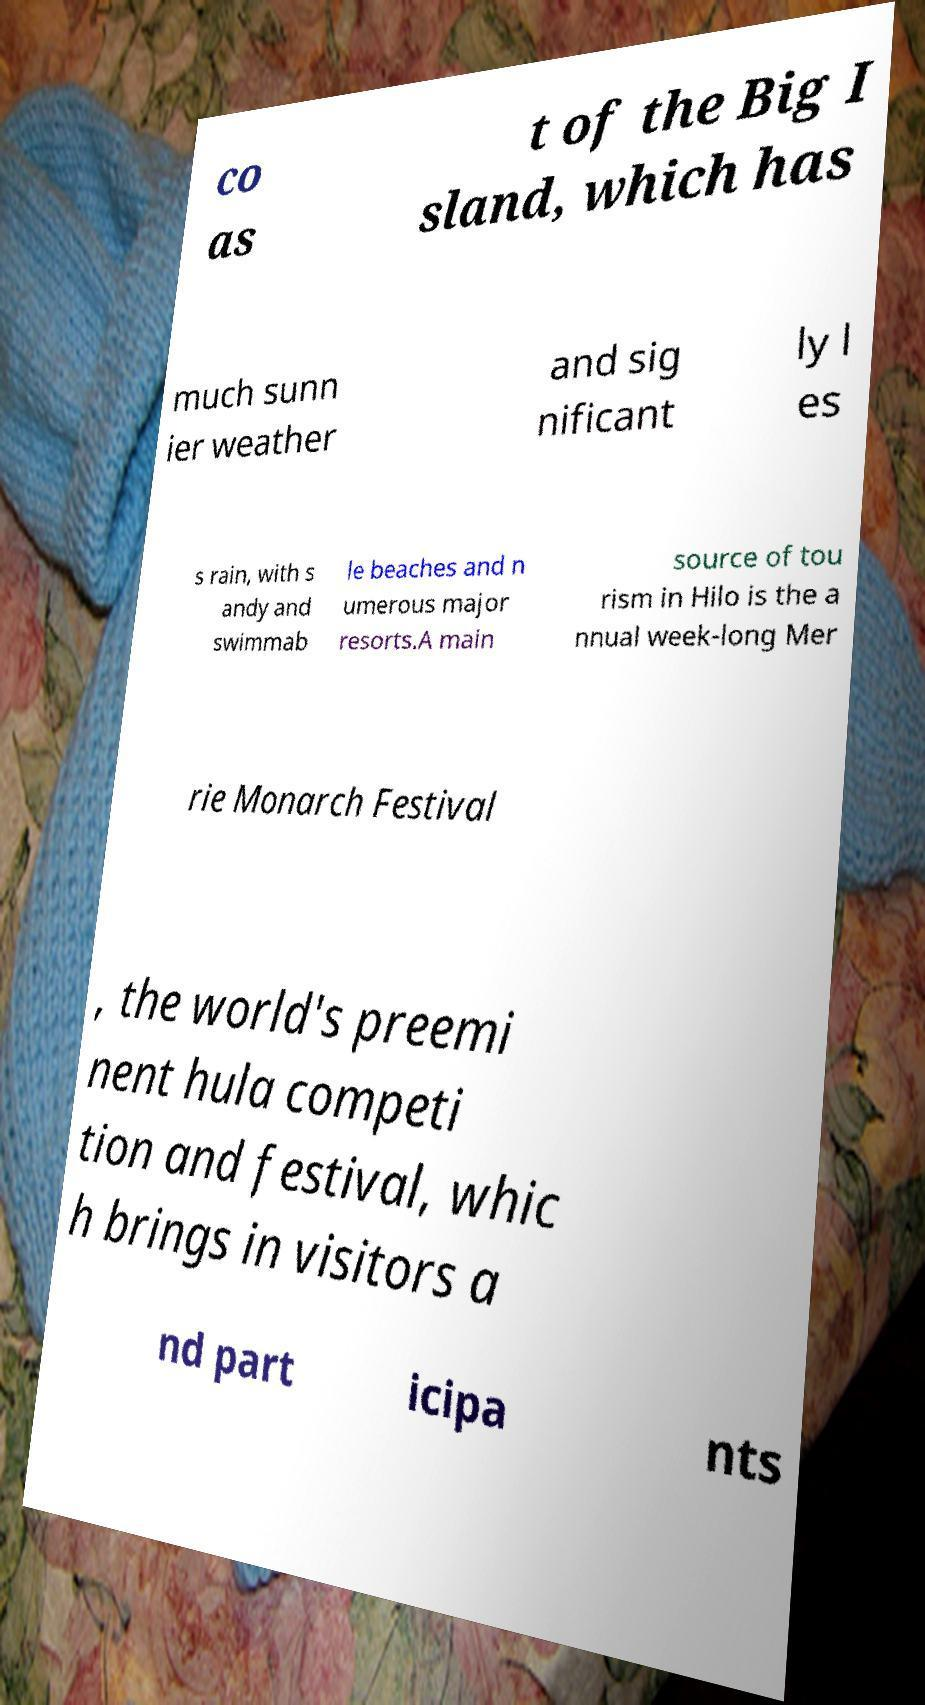Please identify and transcribe the text found in this image. co as t of the Big I sland, which has much sunn ier weather and sig nificant ly l es s rain, with s andy and swimmab le beaches and n umerous major resorts.A main source of tou rism in Hilo is the a nnual week-long Mer rie Monarch Festival , the world's preemi nent hula competi tion and festival, whic h brings in visitors a nd part icipa nts 